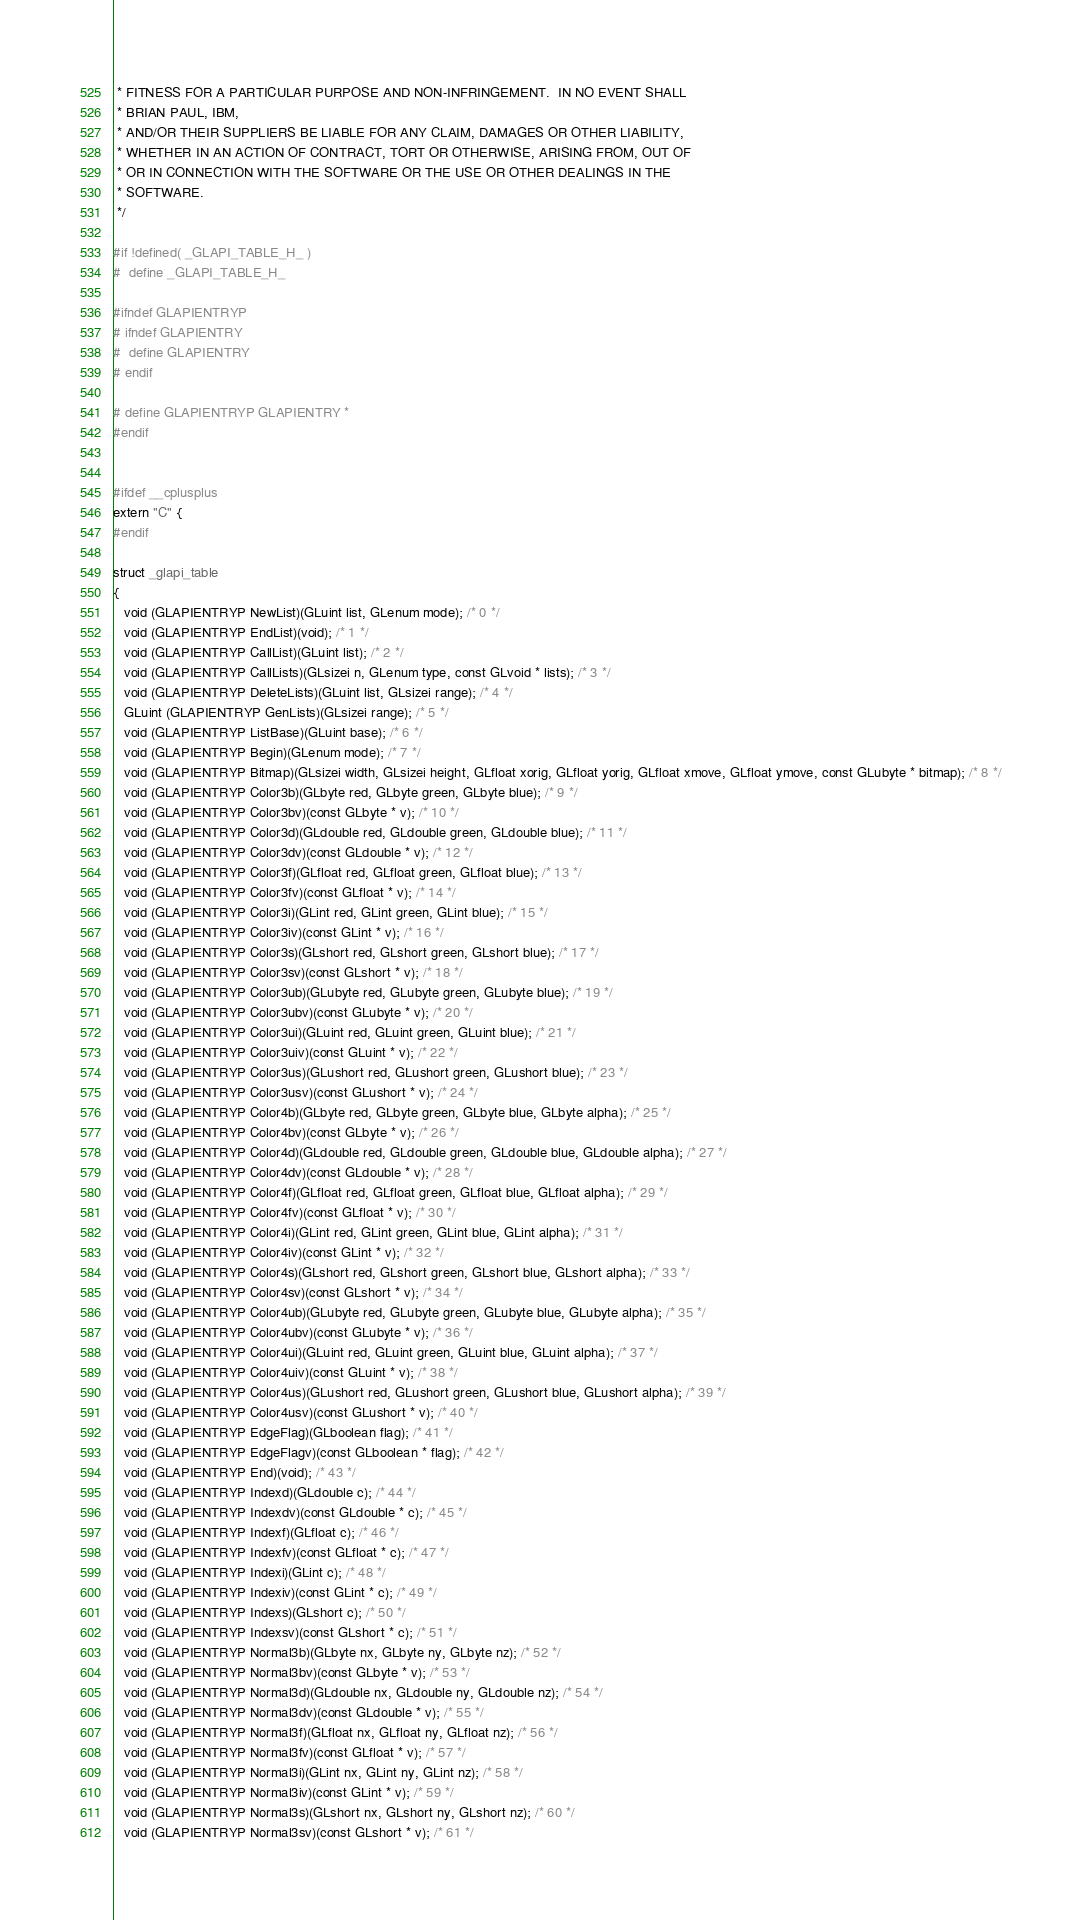Convert code to text. <code><loc_0><loc_0><loc_500><loc_500><_C_> * FITNESS FOR A PARTICULAR PURPOSE AND NON-INFRINGEMENT.  IN NO EVENT SHALL
 * BRIAN PAUL, IBM,
 * AND/OR THEIR SUPPLIERS BE LIABLE FOR ANY CLAIM, DAMAGES OR OTHER LIABILITY,
 * WHETHER IN AN ACTION OF CONTRACT, TORT OR OTHERWISE, ARISING FROM, OUT OF
 * OR IN CONNECTION WITH THE SOFTWARE OR THE USE OR OTHER DEALINGS IN THE
 * SOFTWARE.
 */

#if !defined( _GLAPI_TABLE_H_ )
#  define _GLAPI_TABLE_H_

#ifndef GLAPIENTRYP
# ifndef GLAPIENTRY
#  define GLAPIENTRY
# endif

# define GLAPIENTRYP GLAPIENTRY *
#endif


#ifdef __cplusplus
extern "C" {
#endif

struct _glapi_table
{
   void (GLAPIENTRYP NewList)(GLuint list, GLenum mode); /* 0 */
   void (GLAPIENTRYP EndList)(void); /* 1 */
   void (GLAPIENTRYP CallList)(GLuint list); /* 2 */
   void (GLAPIENTRYP CallLists)(GLsizei n, GLenum type, const GLvoid * lists); /* 3 */
   void (GLAPIENTRYP DeleteLists)(GLuint list, GLsizei range); /* 4 */
   GLuint (GLAPIENTRYP GenLists)(GLsizei range); /* 5 */
   void (GLAPIENTRYP ListBase)(GLuint base); /* 6 */
   void (GLAPIENTRYP Begin)(GLenum mode); /* 7 */
   void (GLAPIENTRYP Bitmap)(GLsizei width, GLsizei height, GLfloat xorig, GLfloat yorig, GLfloat xmove, GLfloat ymove, const GLubyte * bitmap); /* 8 */
   void (GLAPIENTRYP Color3b)(GLbyte red, GLbyte green, GLbyte blue); /* 9 */
   void (GLAPIENTRYP Color3bv)(const GLbyte * v); /* 10 */
   void (GLAPIENTRYP Color3d)(GLdouble red, GLdouble green, GLdouble blue); /* 11 */
   void (GLAPIENTRYP Color3dv)(const GLdouble * v); /* 12 */
   void (GLAPIENTRYP Color3f)(GLfloat red, GLfloat green, GLfloat blue); /* 13 */
   void (GLAPIENTRYP Color3fv)(const GLfloat * v); /* 14 */
   void (GLAPIENTRYP Color3i)(GLint red, GLint green, GLint blue); /* 15 */
   void (GLAPIENTRYP Color3iv)(const GLint * v); /* 16 */
   void (GLAPIENTRYP Color3s)(GLshort red, GLshort green, GLshort blue); /* 17 */
   void (GLAPIENTRYP Color3sv)(const GLshort * v); /* 18 */
   void (GLAPIENTRYP Color3ub)(GLubyte red, GLubyte green, GLubyte blue); /* 19 */
   void (GLAPIENTRYP Color3ubv)(const GLubyte * v); /* 20 */
   void (GLAPIENTRYP Color3ui)(GLuint red, GLuint green, GLuint blue); /* 21 */
   void (GLAPIENTRYP Color3uiv)(const GLuint * v); /* 22 */
   void (GLAPIENTRYP Color3us)(GLushort red, GLushort green, GLushort blue); /* 23 */
   void (GLAPIENTRYP Color3usv)(const GLushort * v); /* 24 */
   void (GLAPIENTRYP Color4b)(GLbyte red, GLbyte green, GLbyte blue, GLbyte alpha); /* 25 */
   void (GLAPIENTRYP Color4bv)(const GLbyte * v); /* 26 */
   void (GLAPIENTRYP Color4d)(GLdouble red, GLdouble green, GLdouble blue, GLdouble alpha); /* 27 */
   void (GLAPIENTRYP Color4dv)(const GLdouble * v); /* 28 */
   void (GLAPIENTRYP Color4f)(GLfloat red, GLfloat green, GLfloat blue, GLfloat alpha); /* 29 */
   void (GLAPIENTRYP Color4fv)(const GLfloat * v); /* 30 */
   void (GLAPIENTRYP Color4i)(GLint red, GLint green, GLint blue, GLint alpha); /* 31 */
   void (GLAPIENTRYP Color4iv)(const GLint * v); /* 32 */
   void (GLAPIENTRYP Color4s)(GLshort red, GLshort green, GLshort blue, GLshort alpha); /* 33 */
   void (GLAPIENTRYP Color4sv)(const GLshort * v); /* 34 */
   void (GLAPIENTRYP Color4ub)(GLubyte red, GLubyte green, GLubyte blue, GLubyte alpha); /* 35 */
   void (GLAPIENTRYP Color4ubv)(const GLubyte * v); /* 36 */
   void (GLAPIENTRYP Color4ui)(GLuint red, GLuint green, GLuint blue, GLuint alpha); /* 37 */
   void (GLAPIENTRYP Color4uiv)(const GLuint * v); /* 38 */
   void (GLAPIENTRYP Color4us)(GLushort red, GLushort green, GLushort blue, GLushort alpha); /* 39 */
   void (GLAPIENTRYP Color4usv)(const GLushort * v); /* 40 */
   void (GLAPIENTRYP EdgeFlag)(GLboolean flag); /* 41 */
   void (GLAPIENTRYP EdgeFlagv)(const GLboolean * flag); /* 42 */
   void (GLAPIENTRYP End)(void); /* 43 */
   void (GLAPIENTRYP Indexd)(GLdouble c); /* 44 */
   void (GLAPIENTRYP Indexdv)(const GLdouble * c); /* 45 */
   void (GLAPIENTRYP Indexf)(GLfloat c); /* 46 */
   void (GLAPIENTRYP Indexfv)(const GLfloat * c); /* 47 */
   void (GLAPIENTRYP Indexi)(GLint c); /* 48 */
   void (GLAPIENTRYP Indexiv)(const GLint * c); /* 49 */
   void (GLAPIENTRYP Indexs)(GLshort c); /* 50 */
   void (GLAPIENTRYP Indexsv)(const GLshort * c); /* 51 */
   void (GLAPIENTRYP Normal3b)(GLbyte nx, GLbyte ny, GLbyte nz); /* 52 */
   void (GLAPIENTRYP Normal3bv)(const GLbyte * v); /* 53 */
   void (GLAPIENTRYP Normal3d)(GLdouble nx, GLdouble ny, GLdouble nz); /* 54 */
   void (GLAPIENTRYP Normal3dv)(const GLdouble * v); /* 55 */
   void (GLAPIENTRYP Normal3f)(GLfloat nx, GLfloat ny, GLfloat nz); /* 56 */
   void (GLAPIENTRYP Normal3fv)(const GLfloat * v); /* 57 */
   void (GLAPIENTRYP Normal3i)(GLint nx, GLint ny, GLint nz); /* 58 */
   void (GLAPIENTRYP Normal3iv)(const GLint * v); /* 59 */
   void (GLAPIENTRYP Normal3s)(GLshort nx, GLshort ny, GLshort nz); /* 60 */
   void (GLAPIENTRYP Normal3sv)(const GLshort * v); /* 61 */</code> 